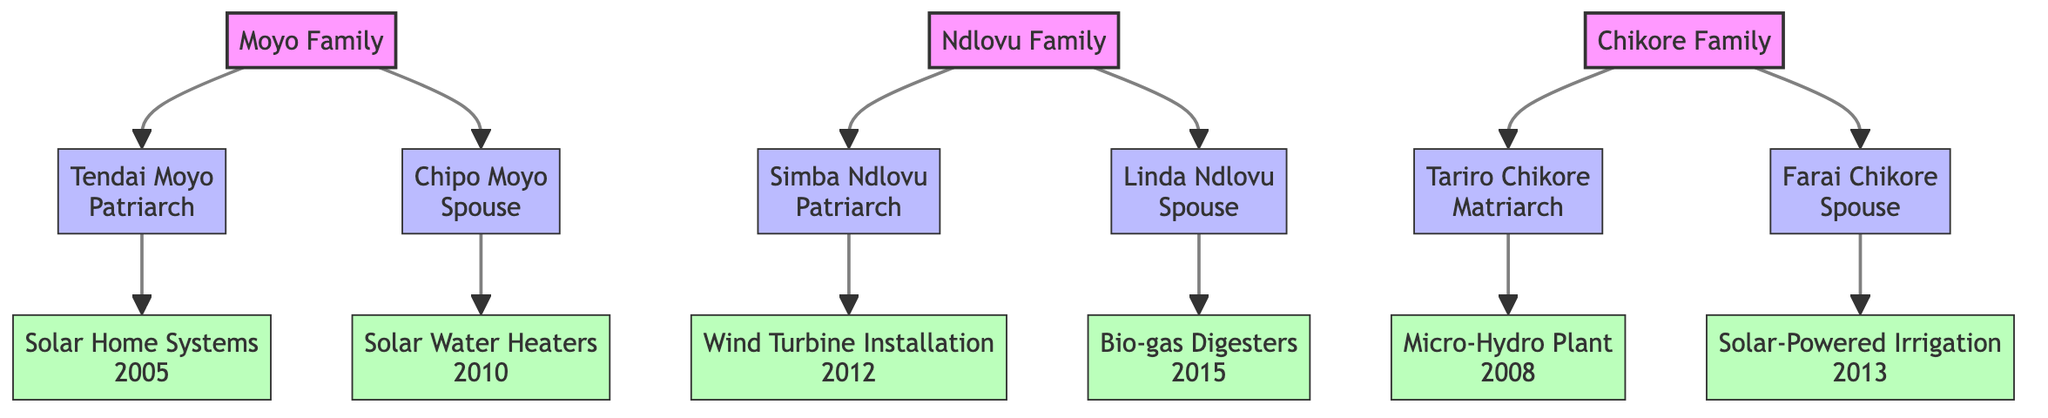What is the surname of the family that established the first solar-powered homes in Seke? According to the diagram, the surname associated with the establishment of the first solar-powered homes in Seke is "Moyo," as mentioned under Tendai Moyo's initiatives.
Answer: Moyo How many families are depicted in the diagram? The diagram clearly shows three families: Moyo, Ndlovu, and Chikore. Thus, there are three distinct family nodes.
Answer: 3 Which project was initiated by Linda Ndlovu? By tracing the connections, we find that Linda Ndlovu is credited with implementing the "Bio-gas Digesters" project, as listed under her initiatives.
Answer: Bio-gas Digesters What was the impact of the project started by Farai Chikore? Analyzing the details of Farai Chikore’s project, we see that he developed "Solar-Powered Irrigation," which had the impact of improving agricultural productivity and water use efficiency.
Answer: Improving agricultural productivity and water use efficiency Which family member organized community workshops to educate on renewable energy benefits? The diagram identifies Chipo Moyo as the family member who organized community workshops to educate about renewable energy benefits, showcasing her influence in the community.
Answer: Chipo Moyo What year did Tendai Moyo implement the Solar Home Systems project? The information presented in the diagram indicates that Tendai Moyo implemented the "Solar Home Systems" project in the year 2005.
Answer: 2005 Which matriarch set up a micro-hydro plant in Seke? The diagram specifies that Tariro Chikore, the matriarch of the Chikore family, set up the micro-hydro plant.
Answer: Tariro Chikore What type of energy solution did Simba Ndlovu advocate for in the community? By reviewing Simba Ndlovu's initiatives in the diagram, it is clear that he advocated for wind energy solutions, specifically through the installation of a community wind turbine.
Answer: Wind energy solutions 